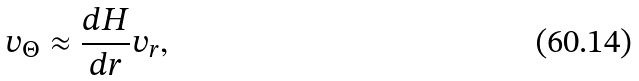Convert formula to latex. <formula><loc_0><loc_0><loc_500><loc_500>v _ { \Theta } \approx \frac { d H } { d r } v _ { r } ,</formula> 